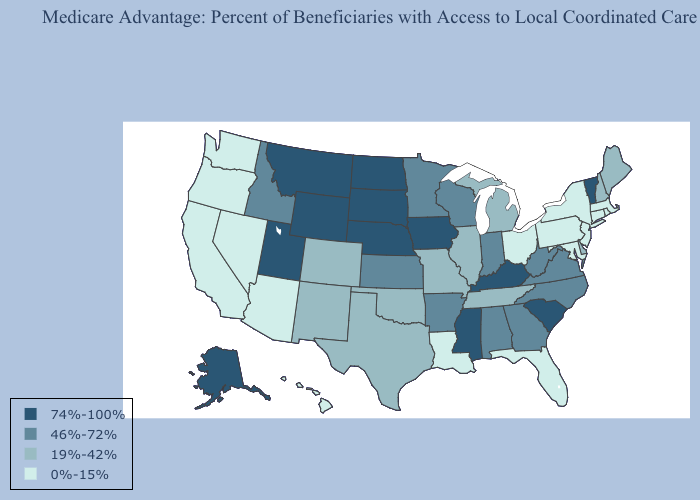Does South Carolina have the lowest value in the USA?
Quick response, please. No. Among the states that border Arizona , does Utah have the highest value?
Quick response, please. Yes. Name the states that have a value in the range 46%-72%?
Give a very brief answer. Alabama, Arkansas, Georgia, Idaho, Indiana, Kansas, Minnesota, North Carolina, Virginia, Wisconsin, West Virginia. What is the value of Arizona?
Quick response, please. 0%-15%. Which states have the highest value in the USA?
Quick response, please. Alaska, Iowa, Kentucky, Mississippi, Montana, North Dakota, Nebraska, South Carolina, South Dakota, Utah, Vermont, Wyoming. What is the value of Alabama?
Short answer required. 46%-72%. Which states hav the highest value in the South?
Write a very short answer. Kentucky, Mississippi, South Carolina. What is the value of Michigan?
Give a very brief answer. 19%-42%. Name the states that have a value in the range 19%-42%?
Give a very brief answer. Colorado, Delaware, Illinois, Maine, Michigan, Missouri, New Hampshire, New Mexico, Oklahoma, Tennessee, Texas. Does Michigan have the lowest value in the USA?
Be succinct. No. Name the states that have a value in the range 46%-72%?
Write a very short answer. Alabama, Arkansas, Georgia, Idaho, Indiana, Kansas, Minnesota, North Carolina, Virginia, Wisconsin, West Virginia. Does Minnesota have a lower value than Oregon?
Give a very brief answer. No. Among the states that border Michigan , does Ohio have the lowest value?
Write a very short answer. Yes. Does Michigan have a lower value than New York?
Write a very short answer. No. Does New Mexico have a higher value than Rhode Island?
Give a very brief answer. Yes. 